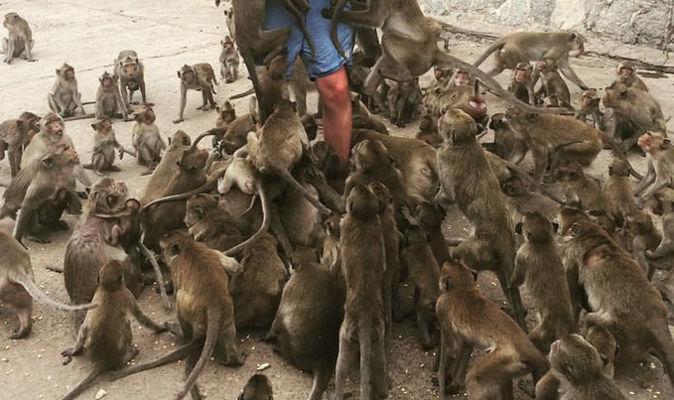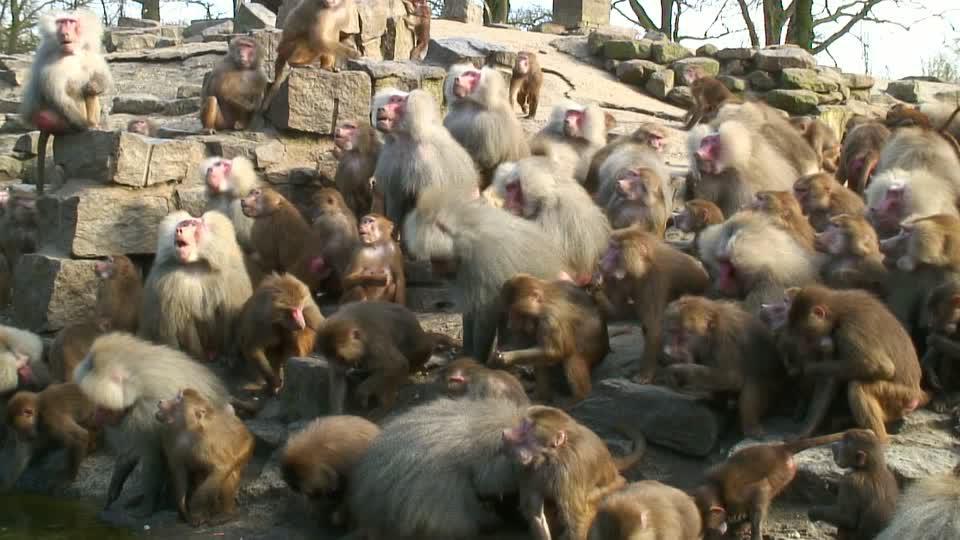The first image is the image on the left, the second image is the image on the right. Evaluate the accuracy of this statement regarding the images: "Bulbous pink rear ends of multiple baboons are visible in one image.". Is it true? Answer yes or no. No. The first image is the image on the left, the second image is the image on the right. Evaluate the accuracy of this statement regarding the images: "A small amount of sky can be seen in the background of the image on the right". Is it true? Answer yes or no. Yes. 